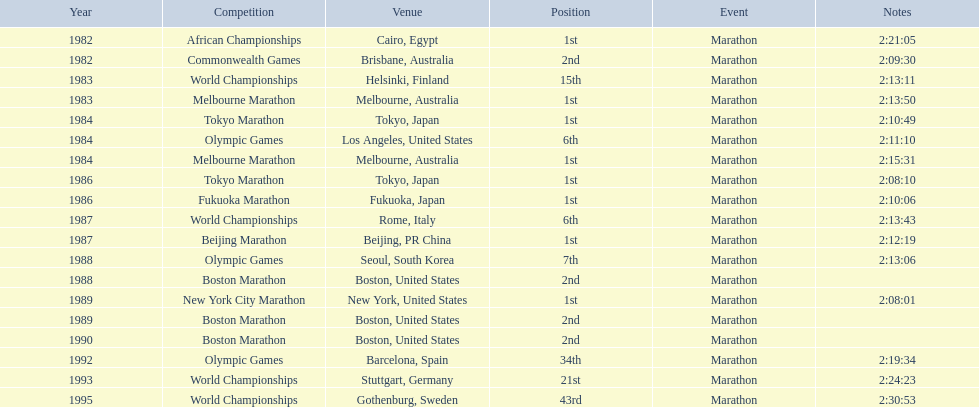What is the comprehensive list of competitions? African Championships, Commonwealth Games, World Championships, Melbourne Marathon, Tokyo Marathon, Olympic Games, Melbourne Marathon, Tokyo Marathon, Fukuoka Marathon, World Championships, Beijing Marathon, Olympic Games, Boston Marathon, New York City Marathon, Boston Marathon, Boston Marathon, Olympic Games, World Championships, World Championships. Where did they take place? Cairo, Egypt, Brisbane, Australia, Helsinki, Finland, Melbourne, Australia, Tokyo, Japan, Los Angeles, United States, Melbourne, Australia, Tokyo, Japan, Fukuoka, Japan, Rome, Italy, Beijing, PR China, Seoul, South Korea, Boston, United States, New York, United States, Boston, United States, Boston, United States, Barcelona, Spain, Stuttgart, Germany, Gothenburg, Sweden. And which one occurred in china? Beijing Marathon. 